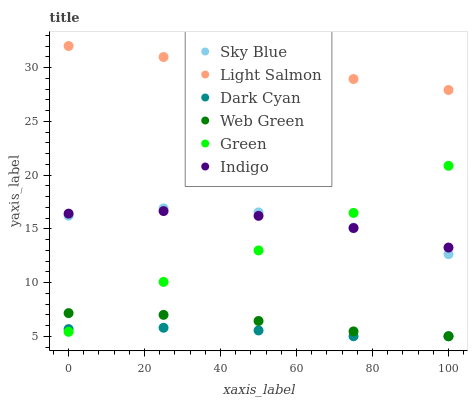Does Dark Cyan have the minimum area under the curve?
Answer yes or no. Yes. Does Light Salmon have the maximum area under the curve?
Answer yes or no. Yes. Does Indigo have the minimum area under the curve?
Answer yes or no. No. Does Indigo have the maximum area under the curve?
Answer yes or no. No. Is Light Salmon the smoothest?
Answer yes or no. Yes. Is Green the roughest?
Answer yes or no. Yes. Is Indigo the smoothest?
Answer yes or no. No. Is Indigo the roughest?
Answer yes or no. No. Does Web Green have the lowest value?
Answer yes or no. Yes. Does Indigo have the lowest value?
Answer yes or no. No. Does Light Salmon have the highest value?
Answer yes or no. Yes. Does Indigo have the highest value?
Answer yes or no. No. Is Dark Cyan less than Sky Blue?
Answer yes or no. Yes. Is Sky Blue greater than Web Green?
Answer yes or no. Yes. Does Indigo intersect Green?
Answer yes or no. Yes. Is Indigo less than Green?
Answer yes or no. No. Is Indigo greater than Green?
Answer yes or no. No. Does Dark Cyan intersect Sky Blue?
Answer yes or no. No. 